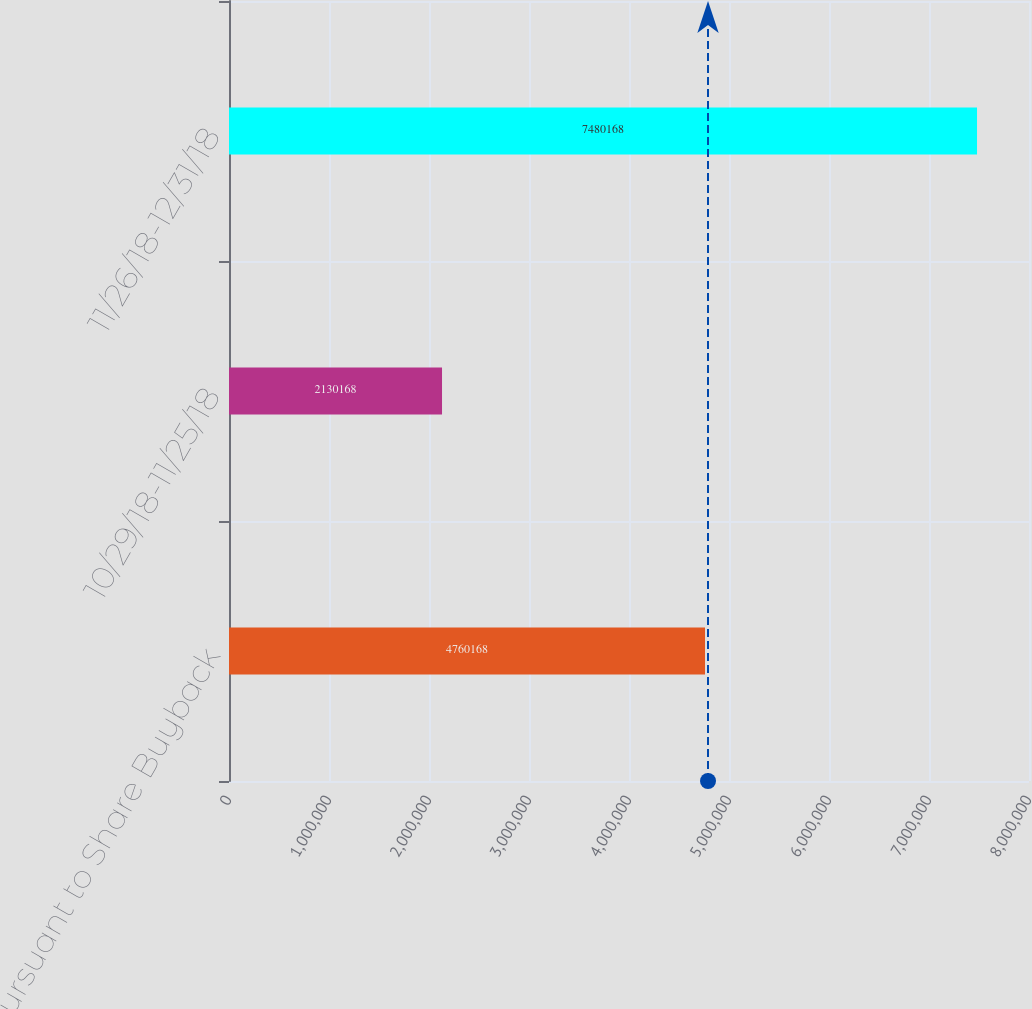Convert chart. <chart><loc_0><loc_0><loc_500><loc_500><bar_chart><fcel>Pursuant to Share Buyback<fcel>10/29/18-11/25/18<fcel>11/26/18-12/31/18<nl><fcel>4.76017e+06<fcel>2.13017e+06<fcel>7.48017e+06<nl></chart> 